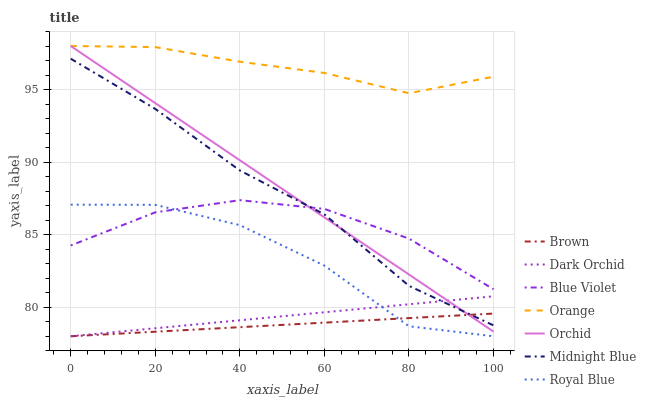Does Brown have the minimum area under the curve?
Answer yes or no. Yes. Does Orange have the maximum area under the curve?
Answer yes or no. Yes. Does Midnight Blue have the minimum area under the curve?
Answer yes or no. No. Does Midnight Blue have the maximum area under the curve?
Answer yes or no. No. Is Orchid the smoothest?
Answer yes or no. Yes. Is Royal Blue the roughest?
Answer yes or no. Yes. Is Midnight Blue the smoothest?
Answer yes or no. No. Is Midnight Blue the roughest?
Answer yes or no. No. Does Brown have the lowest value?
Answer yes or no. Yes. Does Midnight Blue have the lowest value?
Answer yes or no. No. Does Orchid have the highest value?
Answer yes or no. Yes. Does Midnight Blue have the highest value?
Answer yes or no. No. Is Royal Blue less than Orchid?
Answer yes or no. Yes. Is Orchid greater than Royal Blue?
Answer yes or no. Yes. Does Dark Orchid intersect Royal Blue?
Answer yes or no. Yes. Is Dark Orchid less than Royal Blue?
Answer yes or no. No. Is Dark Orchid greater than Royal Blue?
Answer yes or no. No. Does Royal Blue intersect Orchid?
Answer yes or no. No. 